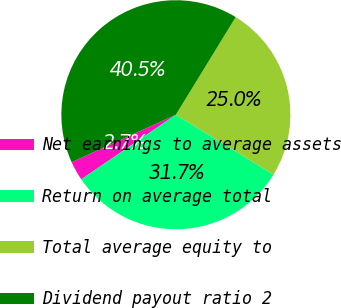<chart> <loc_0><loc_0><loc_500><loc_500><pie_chart><fcel>Net earnings to average assets<fcel>Return on average total<fcel>Total average equity to<fcel>Dividend payout ratio 2<nl><fcel>2.74%<fcel>31.71%<fcel>25.0%<fcel>40.55%<nl></chart> 